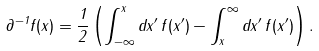<formula> <loc_0><loc_0><loc_500><loc_500>\partial ^ { - 1 } f ( x ) = \frac { 1 } { 2 } \left ( \int _ { - \infty } ^ { x } d x ^ { \prime } \, f ( x ^ { \prime } ) - \int _ { x } ^ { \infty } d x ^ { \prime } \, f ( x ^ { \prime } ) \right ) .</formula> 